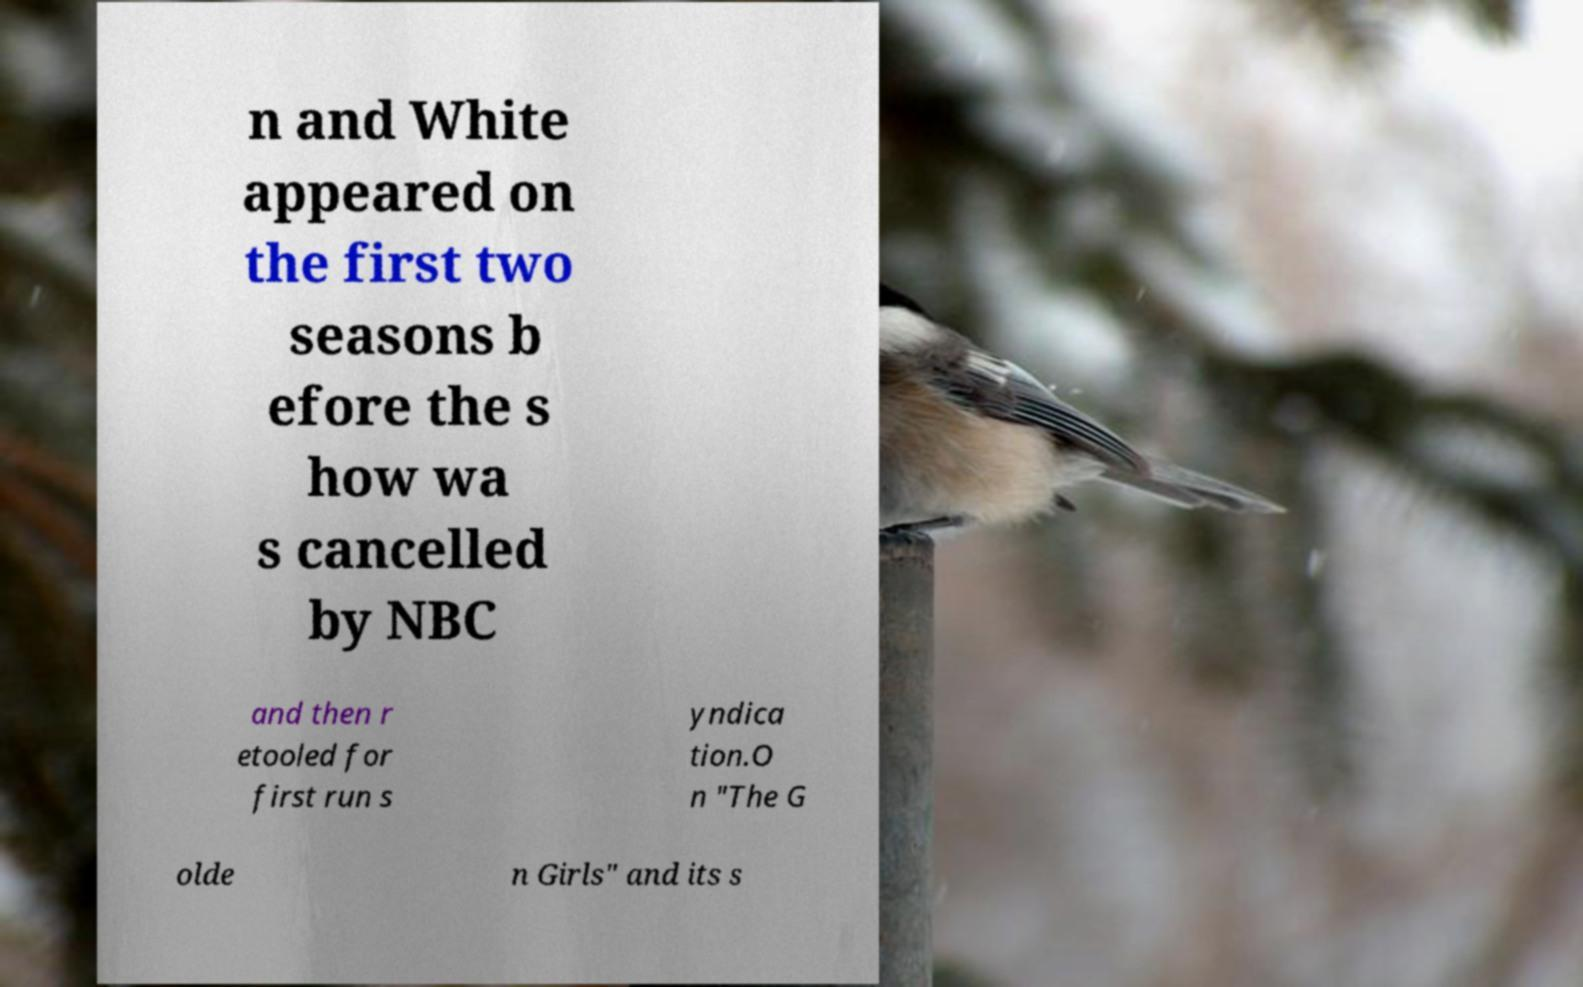Could you assist in decoding the text presented in this image and type it out clearly? n and White appeared on the first two seasons b efore the s how wa s cancelled by NBC and then r etooled for first run s yndica tion.O n "The G olde n Girls" and its s 